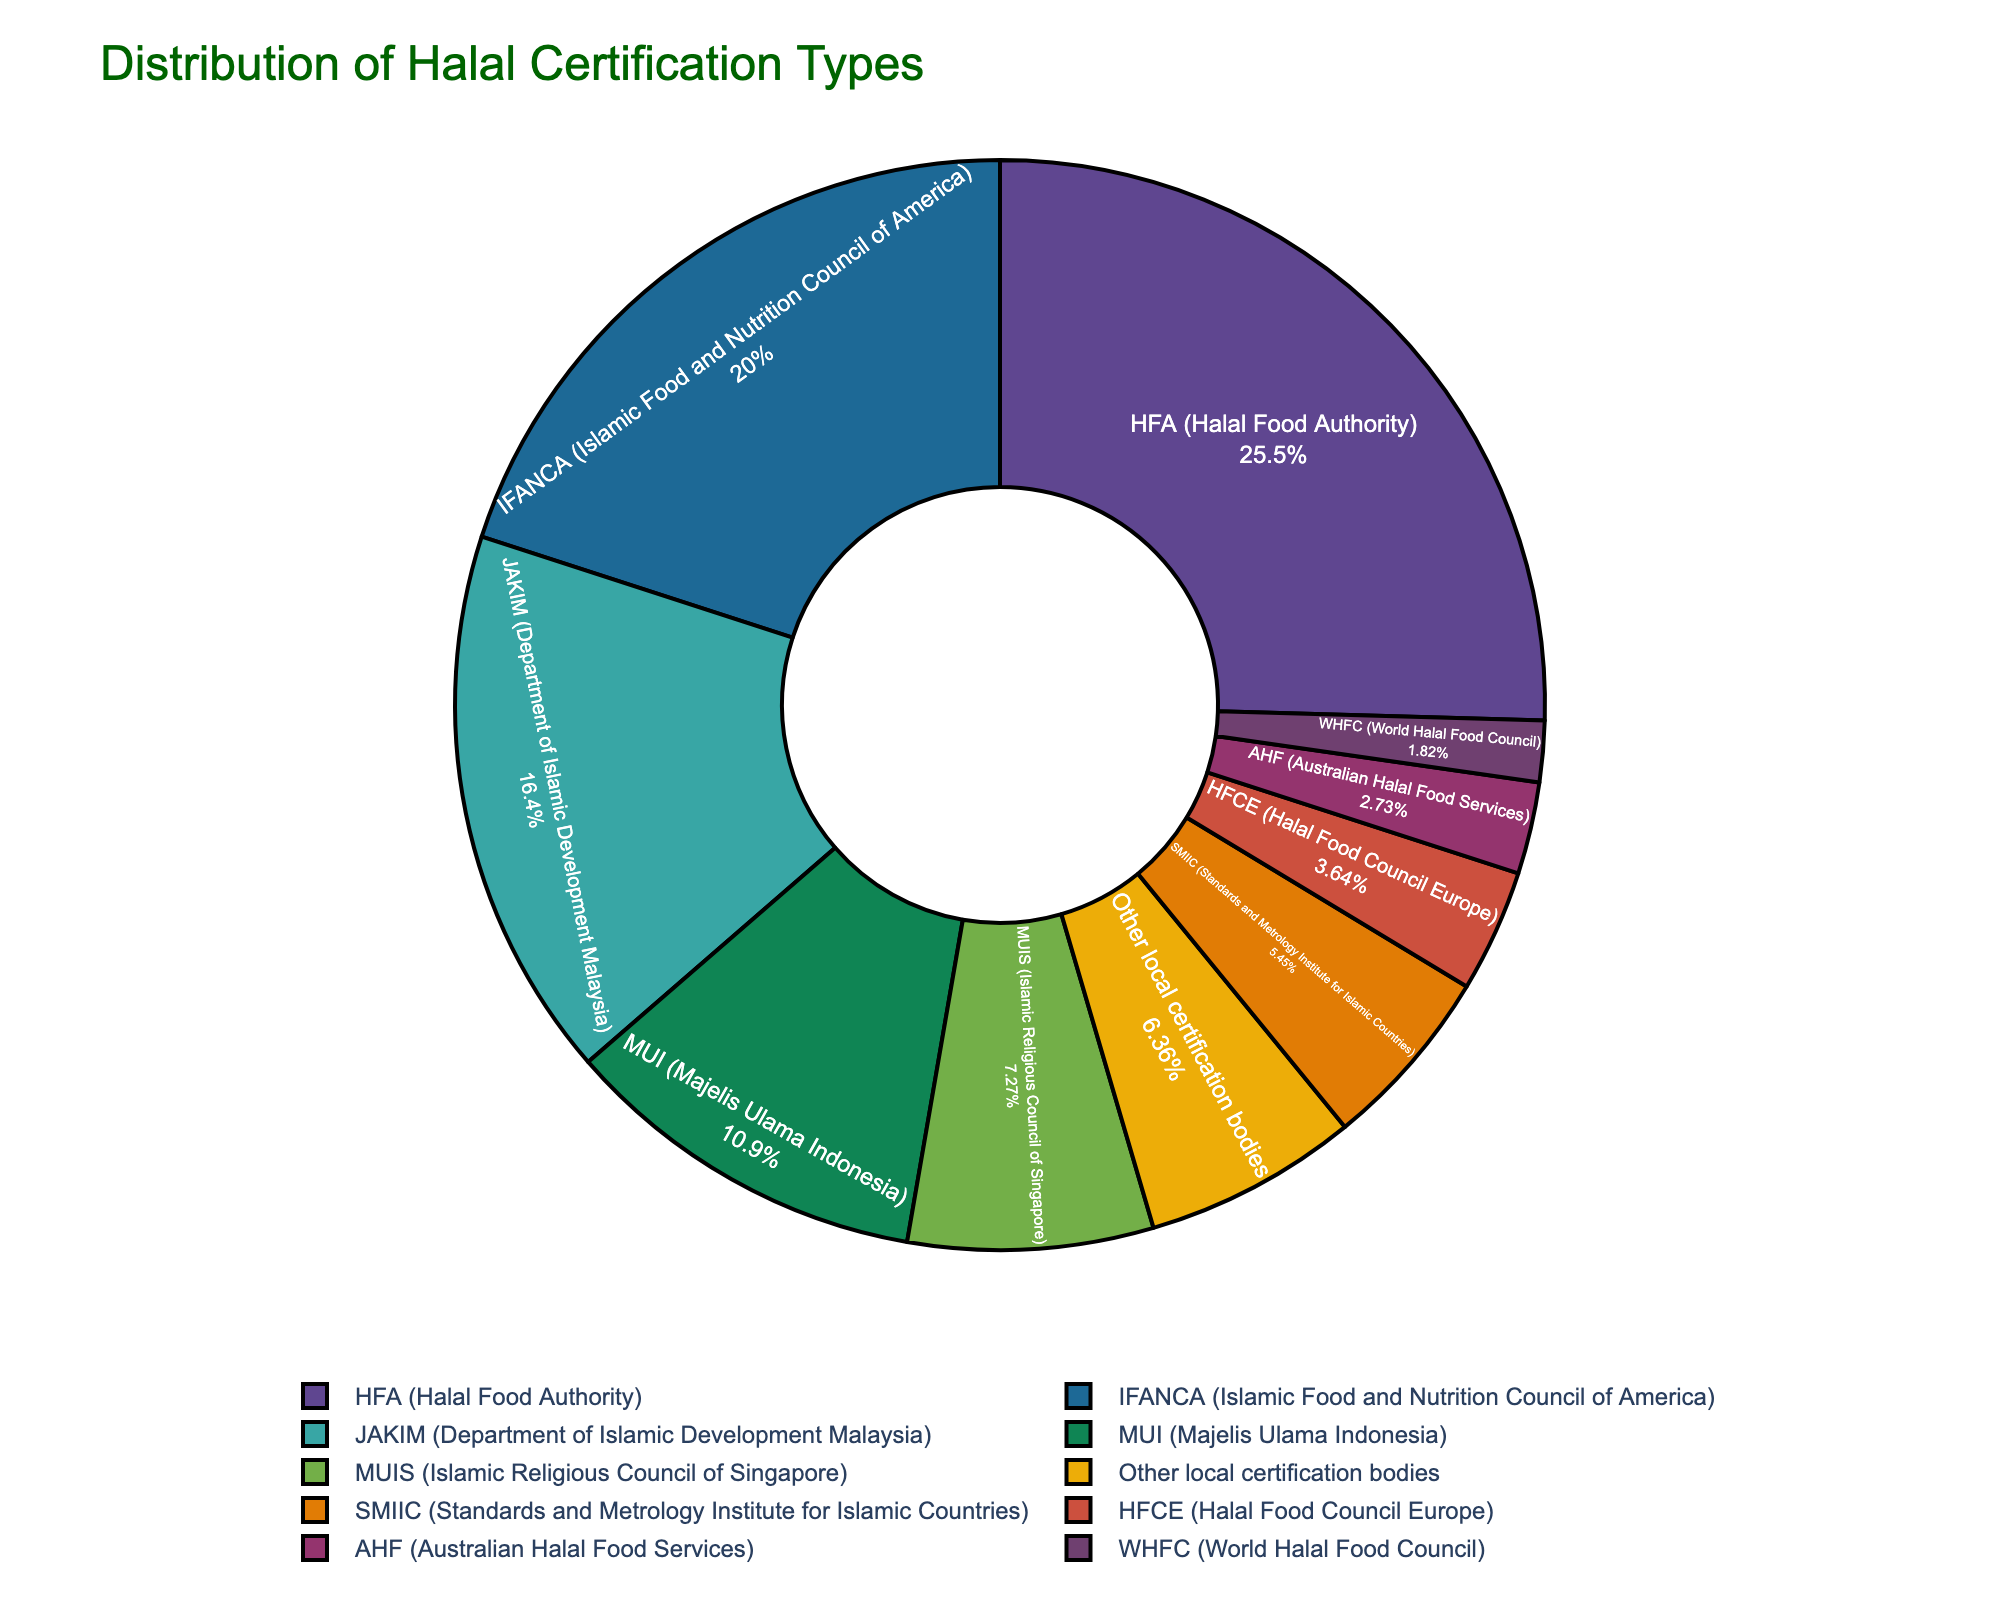What percentage of food processing facilities are certified by IFANCA? The IFANCA certification type has a segment in the pie chart. Referring to the chart, we see that IFANCA represents 22% of the facilities.
Answer: 22% What is the combined percentage of facilities certified by HFA and JAKIM? HFA has 28%, and JAKIM has 18%. Adding these together: 28 + 18 = 46%.
Answer: 46% Which certification type has the smallest representation in the pie chart? By examining the pie chart, the smallest segment corresponds to WHFC, which represents 2% of the facilities.
Answer: WHFC How does the percentage of MUI-certified facilities compare to MUIS-certified facilities? The MUI segment represents 12%, and the MUIS segment represents 8%. Therefore, MUI certification is larger.
Answer: MUI-certified facilities have a higher percentage Between HFA and IFANCA, which certification has a greater share and by how much? HFA has 28%, and IFANCA has 22%. The difference is 28 - 22 = 6%.
Answer: HFA has 6% more What percentage of facilities are certified by bodies other than HFA, IFANCA, and JAKIM? First, sum the percentages for HFA, IFANCA, and JAKIM: 28 + 22 + 18 = 68%. Then, subtract from 100%: 100 - 68 = 32%.
Answer: 32% What is the total percentage for the three certification types MUI, MUIS, and SMIIC? The percentages are MUI 12%, MUIS 8%, and SMIIC 6%. Adding these together: 12 + 8 + 6 = 26%.
Answer: 26% Out of the given certification types, which one has a representation of less than 5%? The chart shows HFCE (4%), AHF (3%), and WHFC (2%) each have less than 5%.
Answer: HFCE, AHF, and WHFC What is the difference in representation between SMIIC and local certification bodies? SMIIC is 6%, and local certification bodies are 7%. The difference is 7 - 6 = 1%.
Answer: 1% 